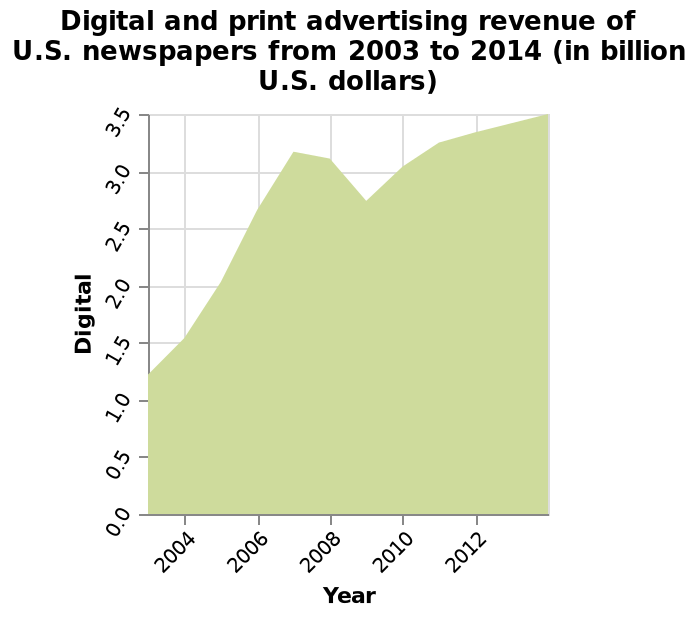<image>
Offer a thorough analysis of the image. As of 2004, the digital and printing advertising revenue was very low but through out the years it kept increasing and in 2012 it was able to reach its highest peak. What happened to the advertising revenue over the years?  The advertising revenue kept increasing over the years. What was the state of digital and printing advertising revenue in 2004?  The digital and printing advertising revenue was very low in 2004. 